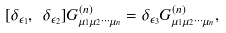<formula> <loc_0><loc_0><loc_500><loc_500>[ \delta _ { \epsilon _ { 1 } } , \ \delta _ { \epsilon _ { 2 } } ] G ^ { ( n ) } _ { \mu _ { 1 } \mu _ { 2 } \cdots \mu _ { n } } = \delta _ { \epsilon _ { 3 } } G ^ { ( n ) } _ { \mu _ { 1 } \mu _ { 2 } \cdots \mu _ { n } } ,</formula> 